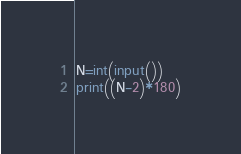Convert code to text. <code><loc_0><loc_0><loc_500><loc_500><_Python_>N=int(input())
print((N-2)*180)</code> 